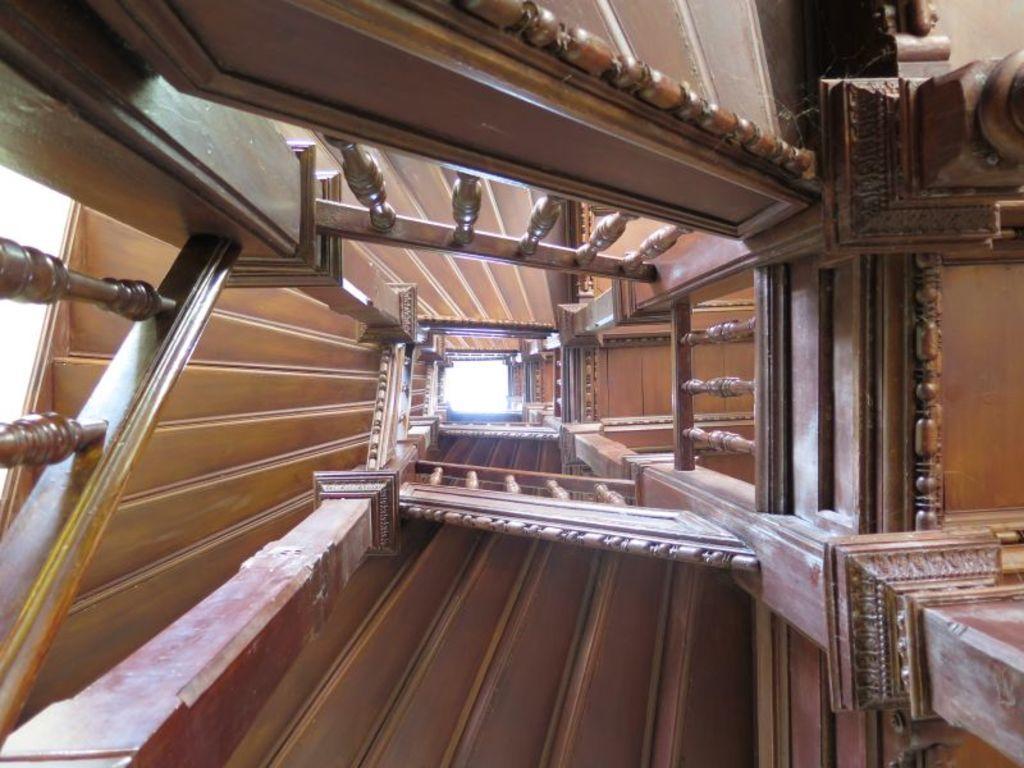Can you describe this image briefly? This picture consists of wooden staircase visible 